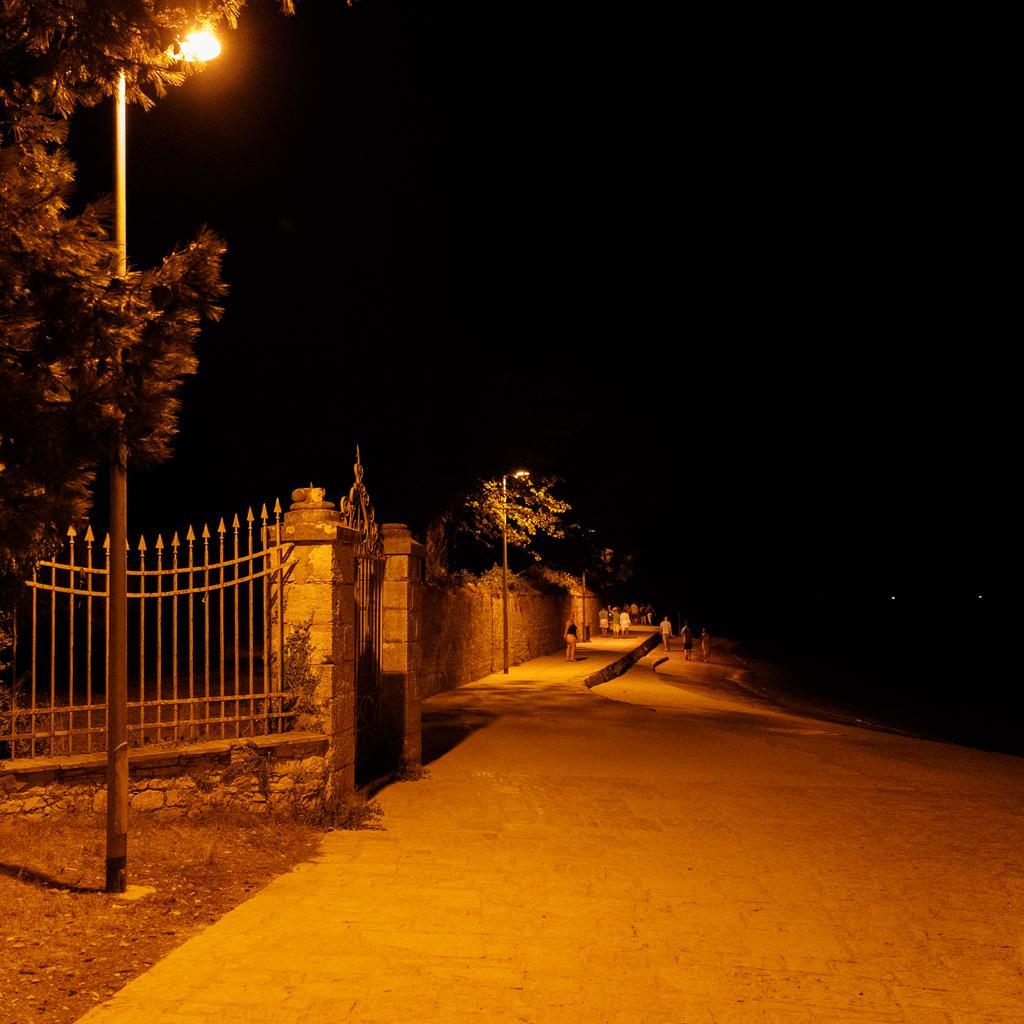How would you summarize this image in a sentence or two? In this image we can see there are people walking on the ground. And there is a wall, to the wall there is a gate. And there are street lights, trees and there is a dark background. 